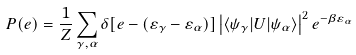<formula> <loc_0><loc_0><loc_500><loc_500>P ( e ) = \frac { 1 } { Z } \sum _ { \gamma , \alpha } \delta [ e - ( \varepsilon _ { \gamma } - \varepsilon _ { \alpha } ) ] \left | \langle \psi _ { \gamma } | U | \psi _ { \alpha } \rangle \right | ^ { 2 } e ^ { - \beta \varepsilon _ { \alpha } }</formula> 